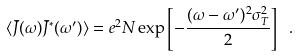<formula> <loc_0><loc_0><loc_500><loc_500>\langle \bar { J } ( \omega ) \bar { J } ^ { * } ( \omega ^ { \prime } ) \rangle = e ^ { 2 } N \exp \left [ - \frac { ( \omega - \omega ^ { \prime } ) ^ { 2 } \sigma ^ { 2 } _ { T } } { 2 } \right ] \ .</formula> 